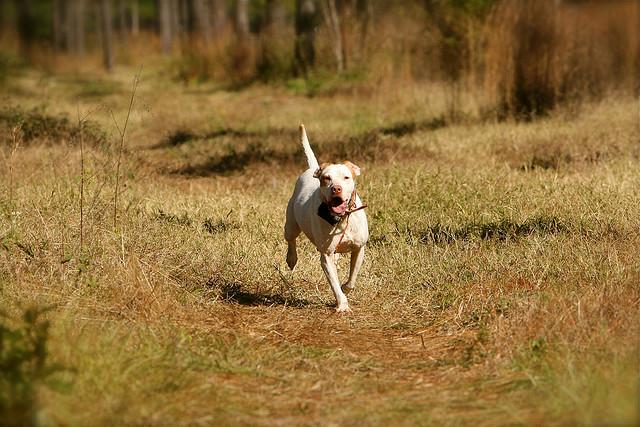Is this outside?
Keep it brief. Yes. What is the dig playing with?
Answer briefly. Stick. What breed of dog is this?
Keep it brief. Pitbull. What color is the dog?
Be succinct. White. Is the dog moving?
Short answer required. Yes. Are there tents in the picture?
Concise answer only. No. 